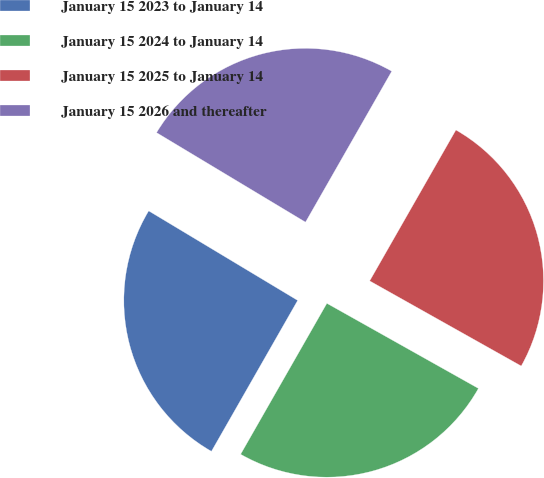Convert chart. <chart><loc_0><loc_0><loc_500><loc_500><pie_chart><fcel>January 15 2023 to January 14<fcel>January 15 2024 to January 14<fcel>January 15 2025 to January 14<fcel>January 15 2026 and thereafter<nl><fcel>25.35%<fcel>25.12%<fcel>24.88%<fcel>24.65%<nl></chart> 